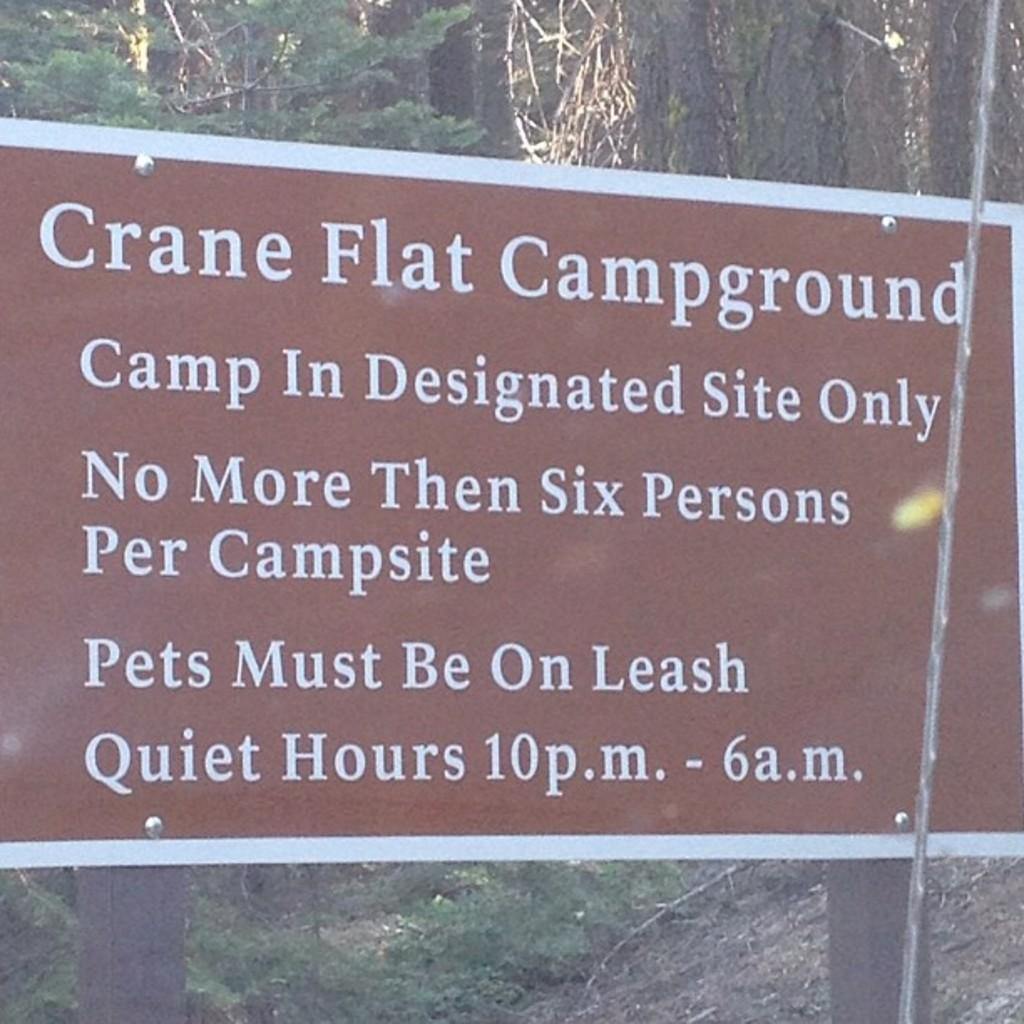What is the main object in the front of the image? There is a name board in the front of the image. What can be seen behind the name board? Trees are visible in the image. Where are the trees located? The trees are on the land. What type of fear can be seen on the name board in the image? There is no fear present on the name board in the image; it is simply a board displaying a name. 